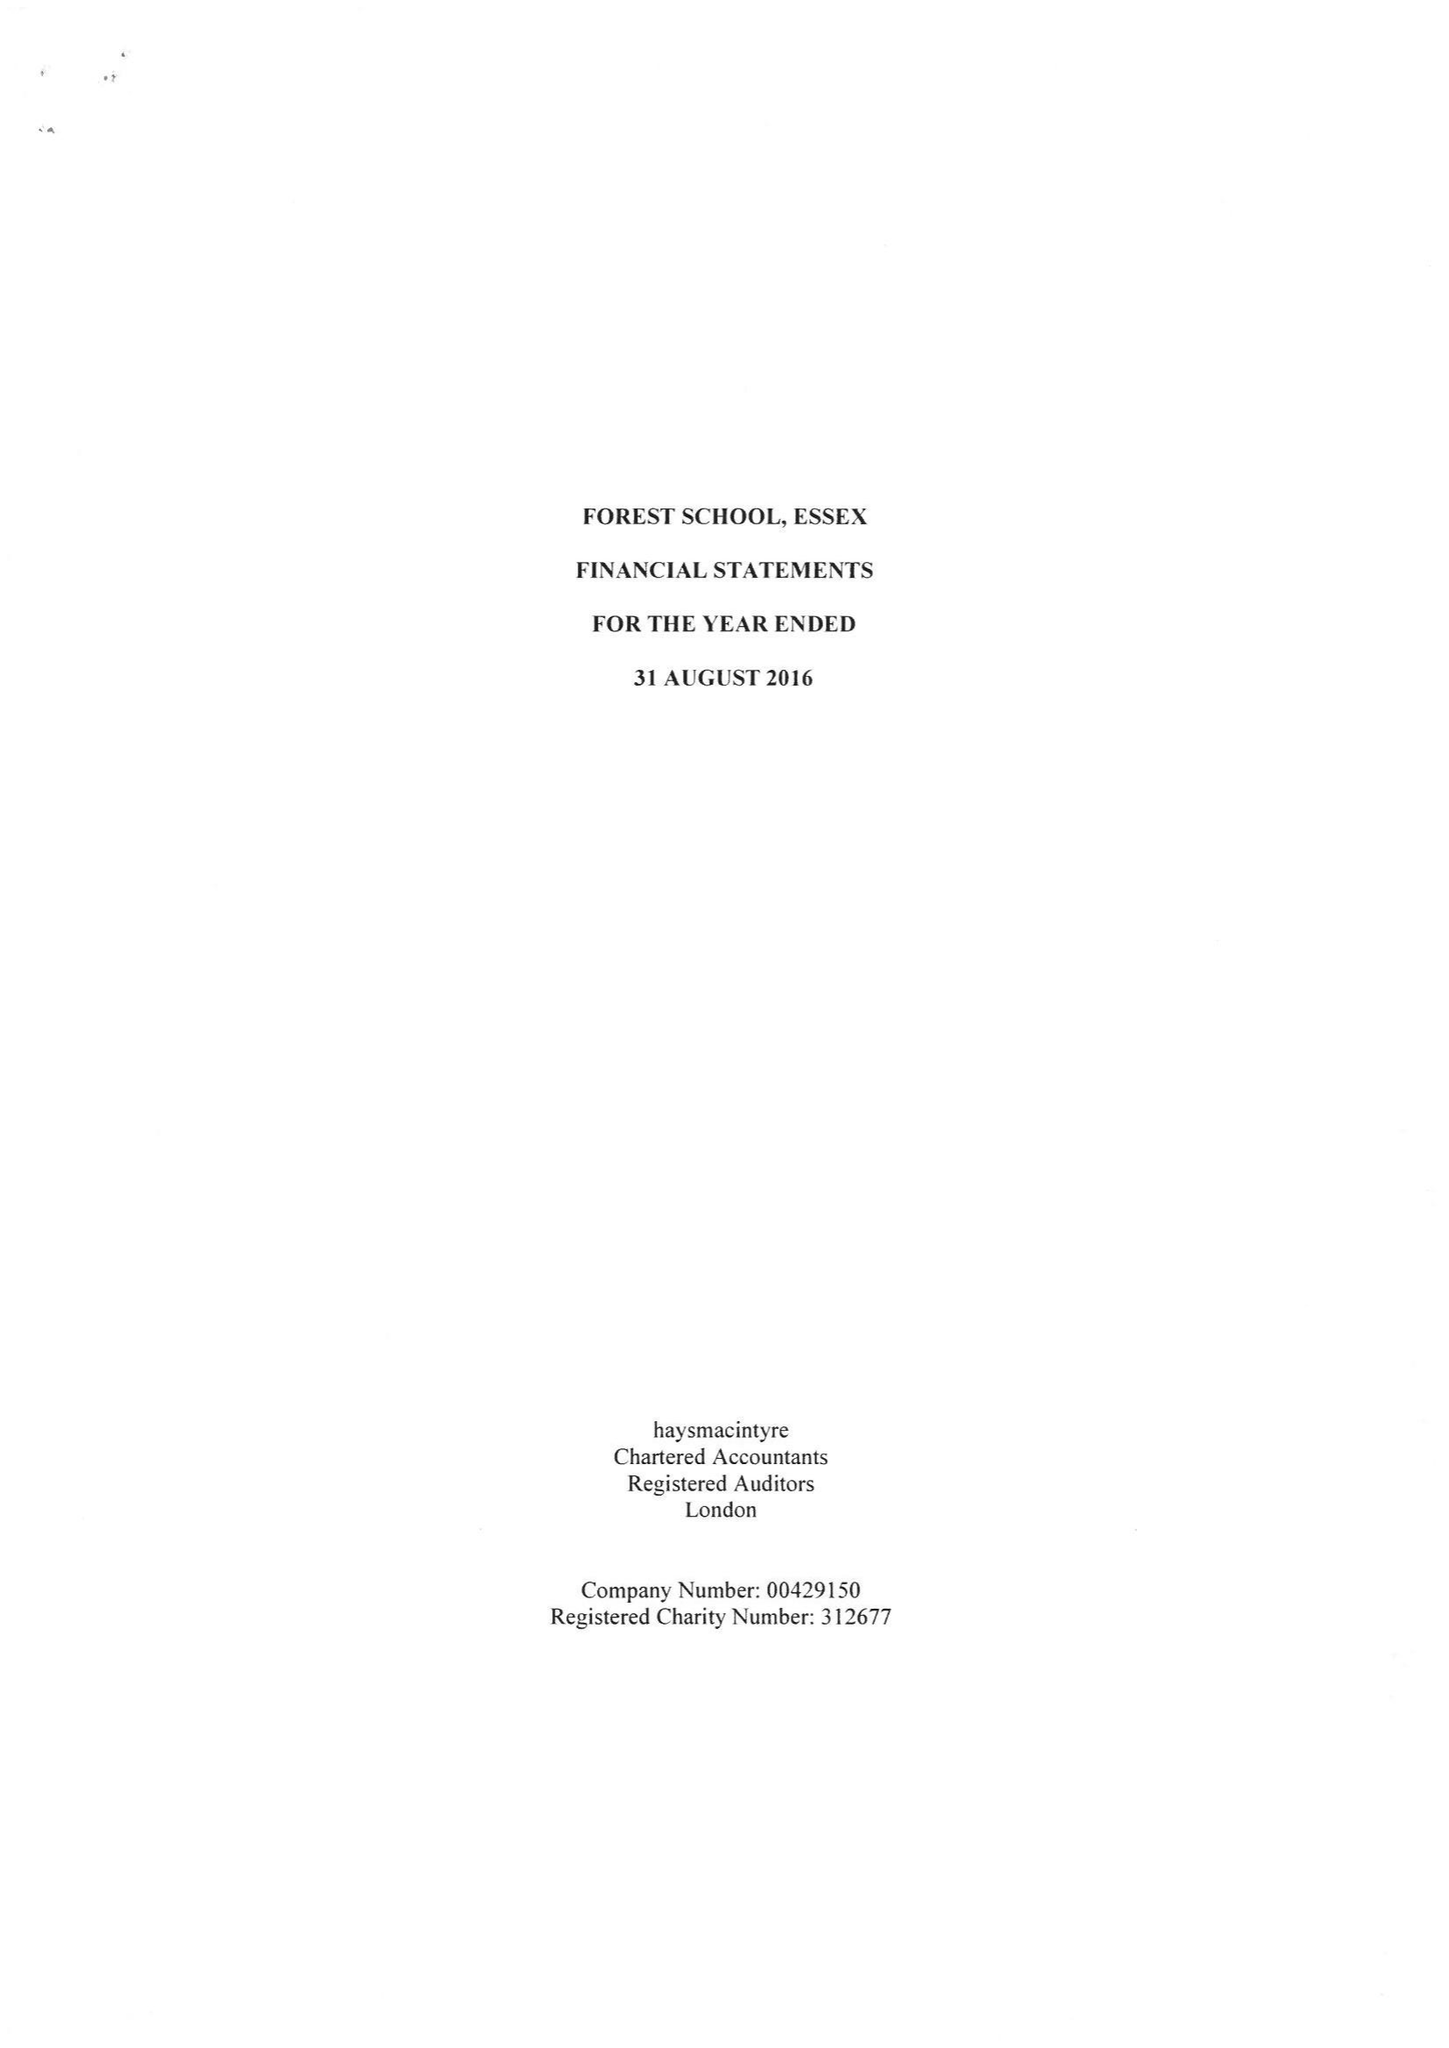What is the value for the address__street_line?
Answer the question using a single word or phrase. COLLEGE PLACE 